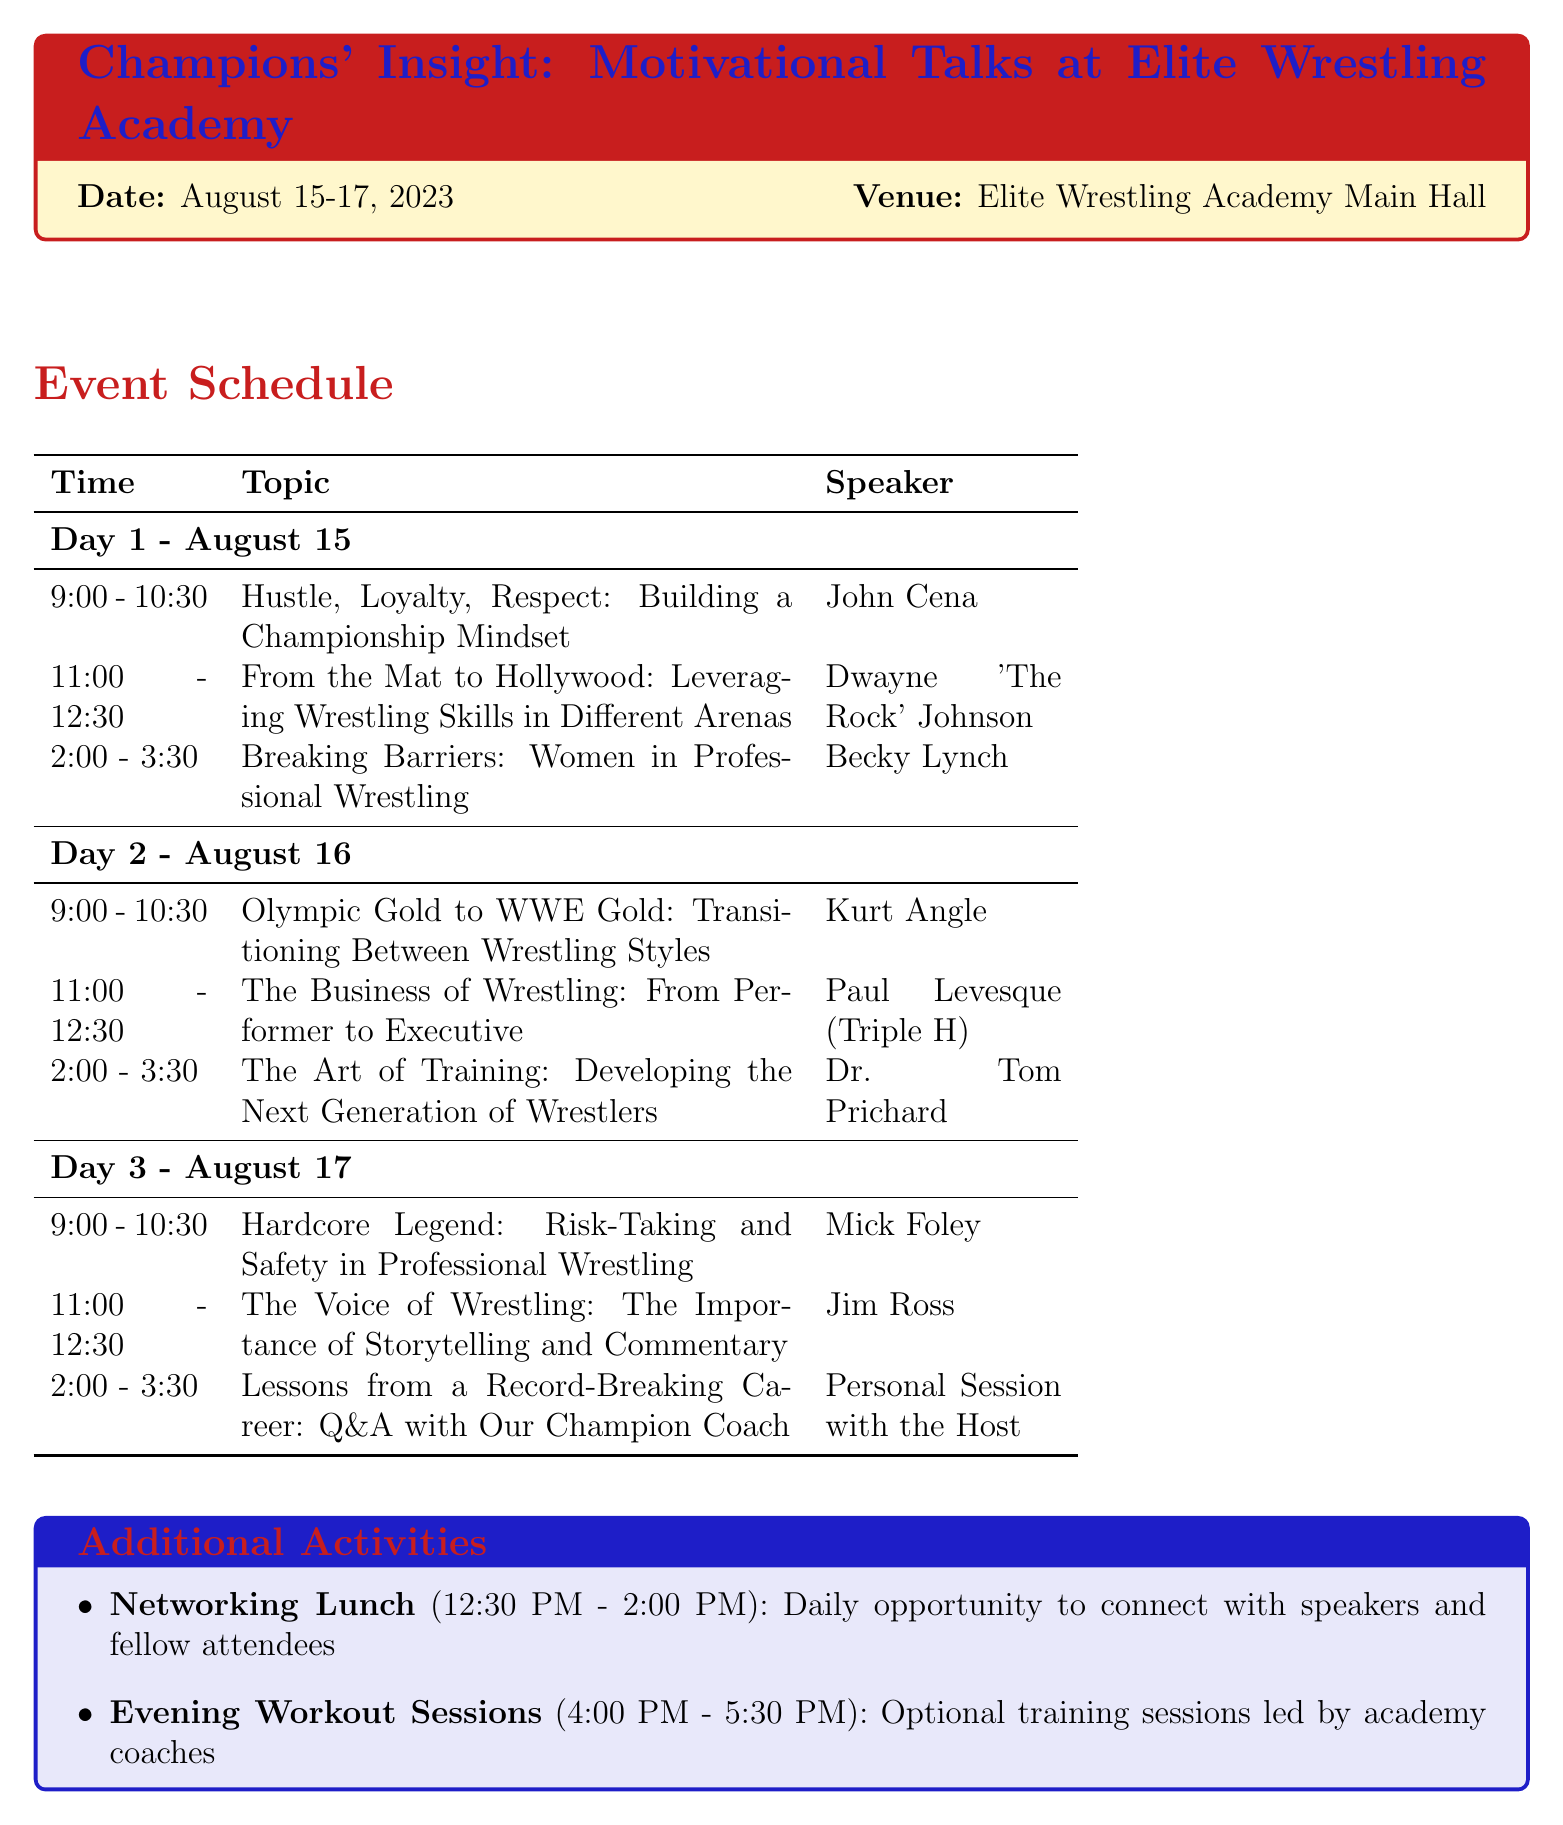What is the name of the event? The event name is provided at the top of the document, which is "Champions' Insight: Motivational Talks at Elite Wrestling Academy."
Answer: Champions' Insight: Motivational Talks at Elite Wrestling Academy On which date does the event take place? The event occurs over three days, and the date is specifically mentioned as "August 15-17, 2023."
Answer: August 15-17, 2023 Who is speaking about "Hustle, Loyalty, Respect"? The speaker's name associated with that topic is listed in the schedule.
Answer: John Cena What time does the session with Mick Foley start? The time for Mick Foley's session is detailed in the schedule under Day 3.
Answer: 9:00 AM How many speakers are featured on Day 1? The document lists the number of speakers for Day 1 under the specific heading for that day.
Answer: 3 What is the topic of the last session on the last day? The last topic of the last day's session is explicitly stated in the schedule.
Answer: Lessons from a Record-Breaking Career: Q&A with Our Champion Coach What type of opportunities does the Networking Lunch provide? The description of the Networking Lunch outlines the purpose of this activity.
Answer: Connect with speakers and fellow attendees What is the expected outcome related to the business side of wrestling? The expected outcomes section lists insights related to the business of wrestling.
Answer: Insights into the business side of wrestling 